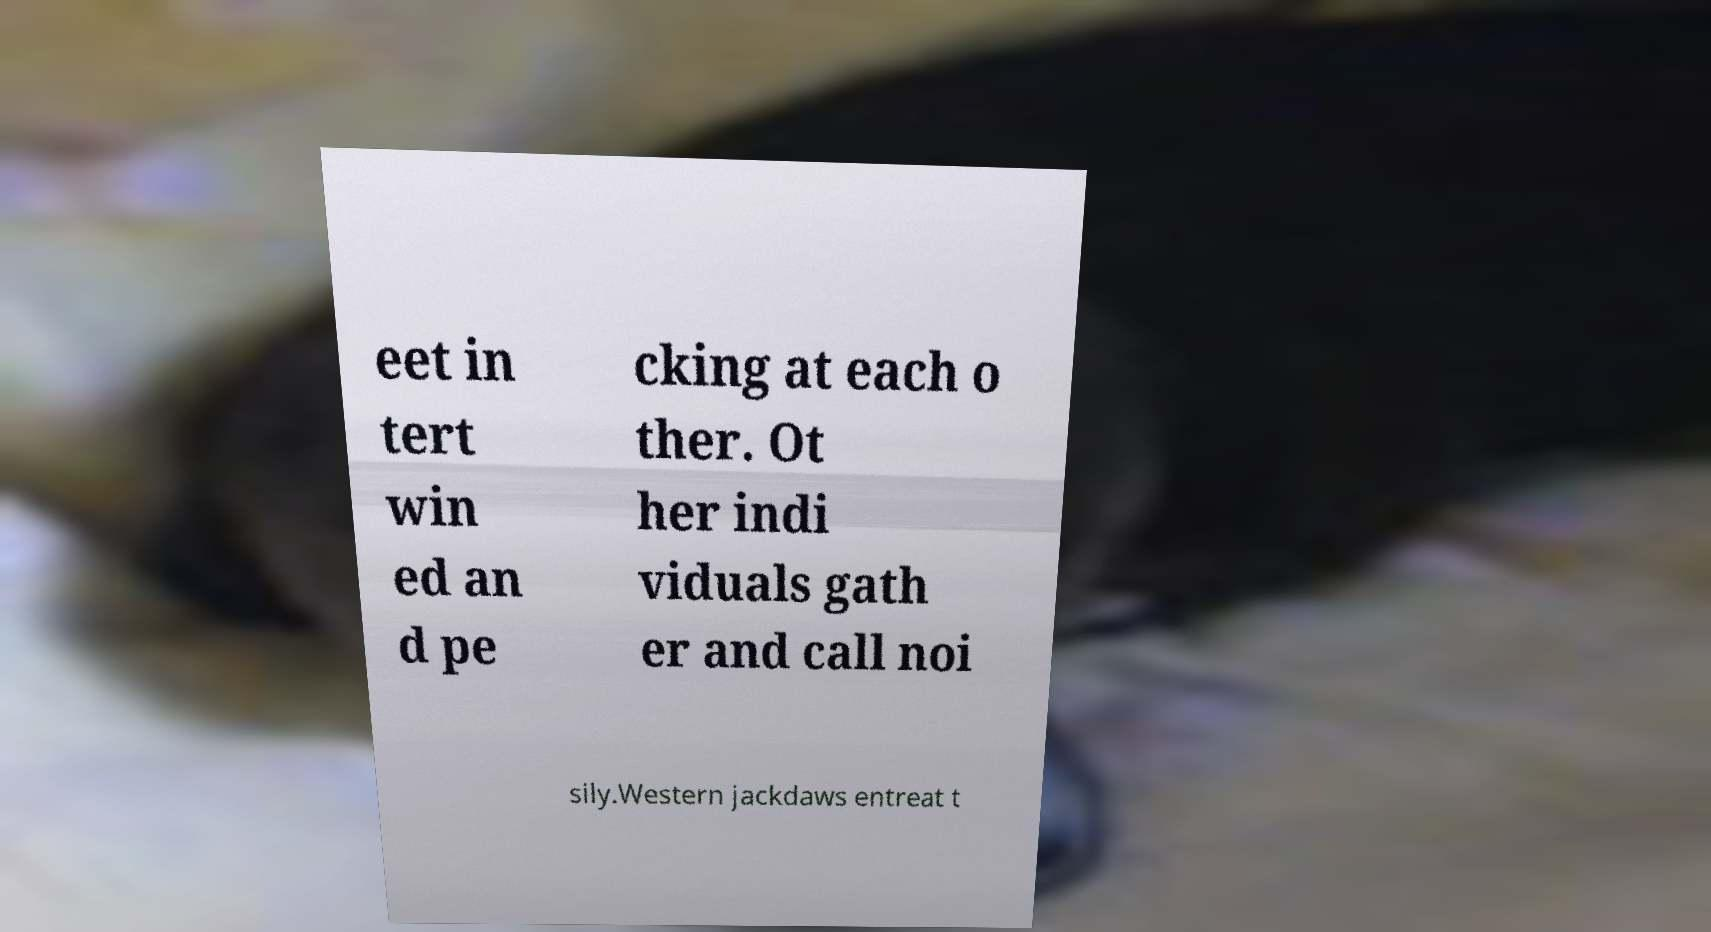Could you assist in decoding the text presented in this image and type it out clearly? eet in tert win ed an d pe cking at each o ther. Ot her indi viduals gath er and call noi sily.Western jackdaws entreat t 